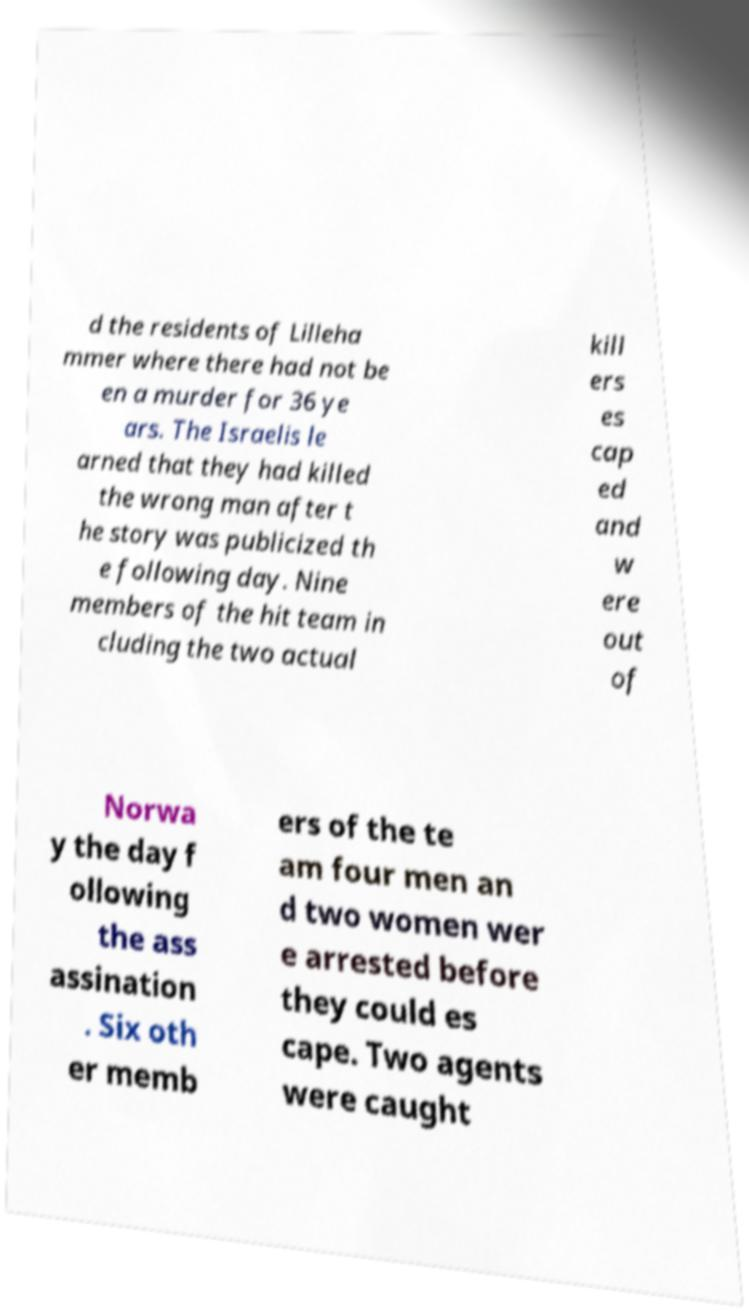Please identify and transcribe the text found in this image. d the residents of Lilleha mmer where there had not be en a murder for 36 ye ars. The Israelis le arned that they had killed the wrong man after t he story was publicized th e following day. Nine members of the hit team in cluding the two actual kill ers es cap ed and w ere out of Norwa y the day f ollowing the ass assination . Six oth er memb ers of the te am four men an d two women wer e arrested before they could es cape. Two agents were caught 